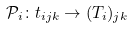<formula> <loc_0><loc_0><loc_500><loc_500>\mathcal { P } _ { i } \colon t _ { i j k } \to ( T _ { i } ) _ { j k }</formula> 